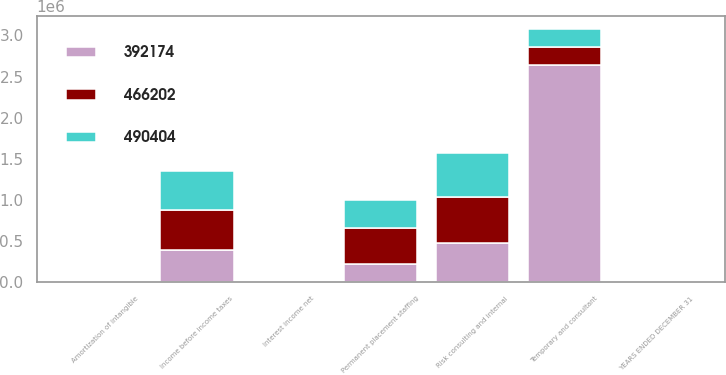Convert chart to OTSL. <chart><loc_0><loc_0><loc_500><loc_500><stacked_bar_chart><ecel><fcel>YEARS ENDED DECEMBER 31<fcel>Temporary and consultant<fcel>Permanent placement staffing<fcel>Risk consulting and internal<fcel>Amortization of intangible<fcel>Interest income net<fcel>Income before income taxes<nl><fcel>466202<fcel>2007<fcel>219234<fcel>444090<fcel>552302<fcel>2594<fcel>13127<fcel>490404<nl><fcel>490404<fcel>2006<fcel>219234<fcel>336250<fcel>543410<fcel>851<fcel>16752<fcel>466202<nl><fcel>392174<fcel>2005<fcel>2.64021e+06<fcel>219234<fcel>478994<fcel>335<fcel>10948<fcel>392174<nl></chart> 